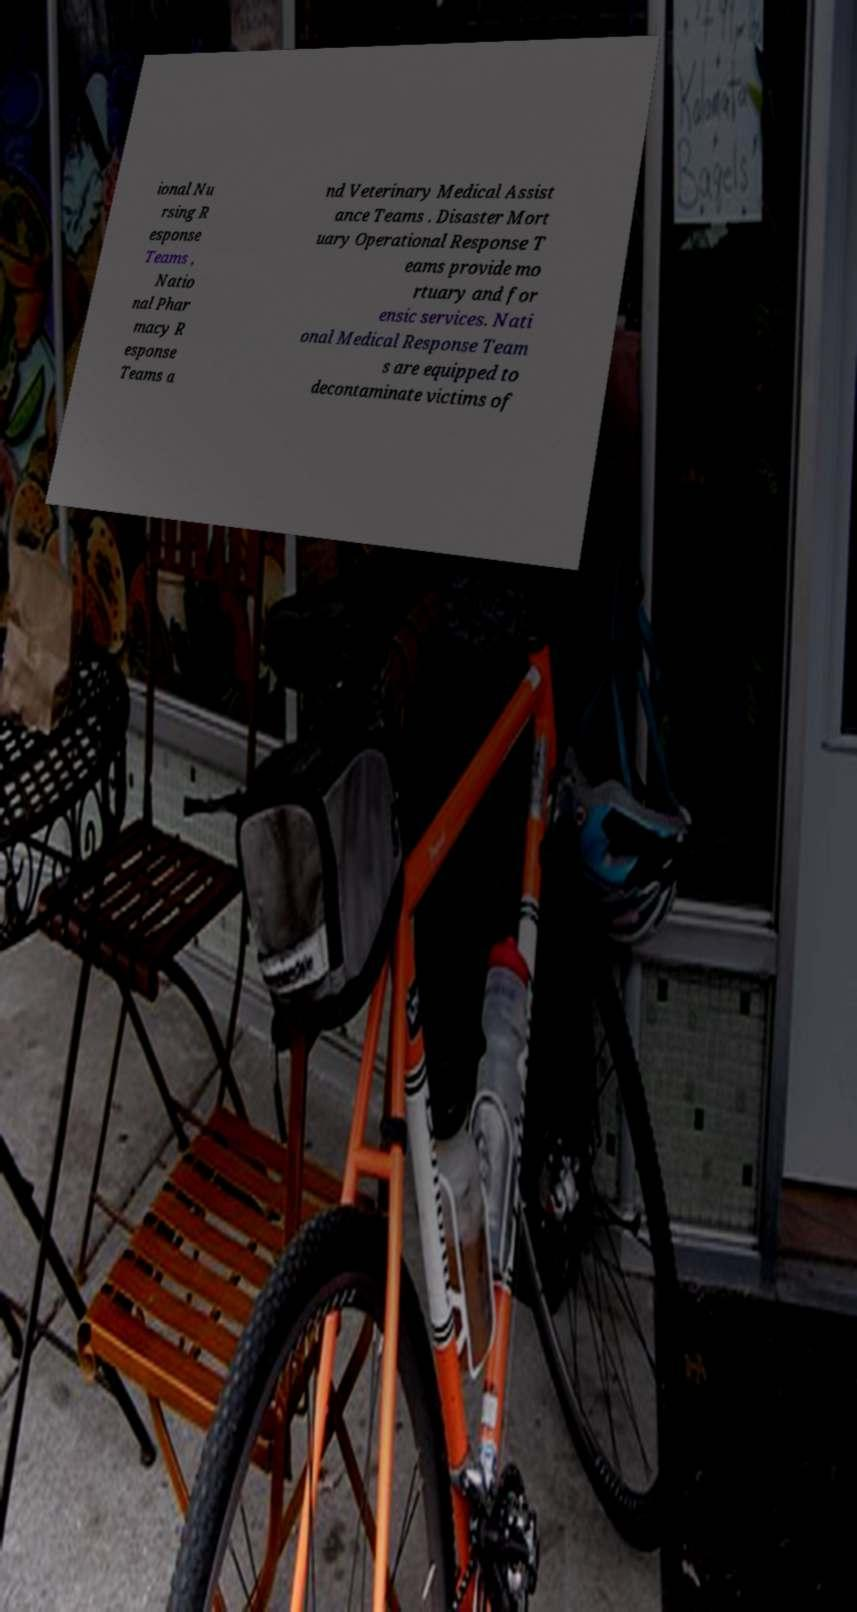Could you assist in decoding the text presented in this image and type it out clearly? ional Nu rsing R esponse Teams , Natio nal Phar macy R esponse Teams a nd Veterinary Medical Assist ance Teams . Disaster Mort uary Operational Response T eams provide mo rtuary and for ensic services. Nati onal Medical Response Team s are equipped to decontaminate victims of 